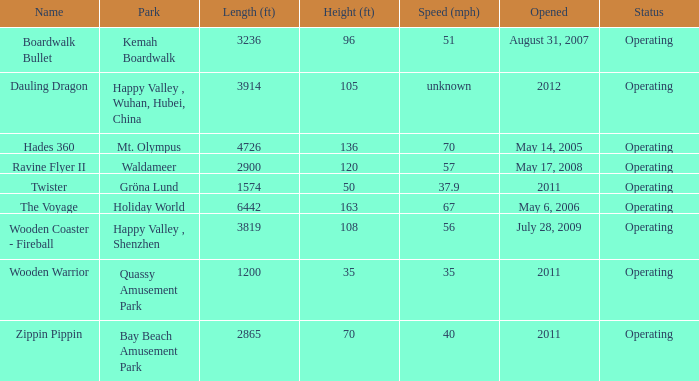How extensive is the kemah boardwalk roller coaster? 3236.0. 